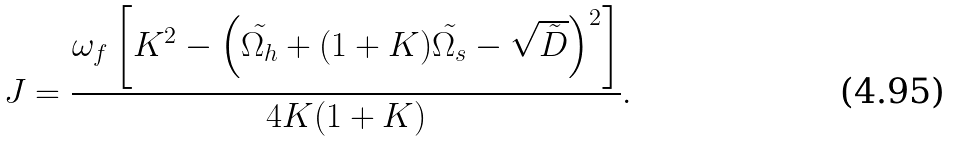Convert formula to latex. <formula><loc_0><loc_0><loc_500><loc_500>J = \frac { \omega _ { f } \left [ K ^ { 2 } - \left ( { \tilde { \Omega _ { h } } } + ( 1 + K ) { \tilde { \Omega _ { s } } } - \sqrt { { \tilde { D } } } \right ) ^ { 2 } \right ] } { 4 K ( 1 + K ) } .</formula> 